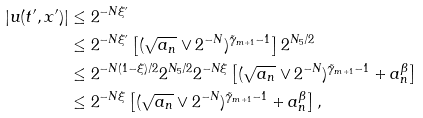Convert formula to latex. <formula><loc_0><loc_0><loc_500><loc_500>| u ( t ^ { \prime } , x ^ { \prime } ) | & \leq 2 ^ { - N \xi ^ { \prime } } \\ & \leq 2 ^ { - N \xi ^ { \prime } } \left [ ( \sqrt { a _ { n } } \vee 2 ^ { - N } ) ^ { \tilde { \gamma } _ { m + 1 } - 1 } \right ] 2 ^ { N _ { 5 } / 2 } \\ & \leq 2 ^ { - N ( 1 - \xi ) / 2 } 2 ^ { N _ { 5 } / 2 } 2 ^ { - N \xi } \left [ ( \sqrt { a _ { n } } \vee 2 ^ { - N } ) ^ { \tilde { \gamma } _ { m + 1 } - 1 } + a _ { n } ^ { \beta } \right ] \\ & \leq 2 ^ { - N \xi } \left [ ( \sqrt { a _ { n } } \vee 2 ^ { - N } ) ^ { \tilde { \gamma } _ { m + 1 } - 1 } + a _ { n } ^ { \beta } \right ] ,</formula> 